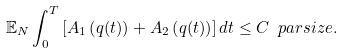<formula> <loc_0><loc_0><loc_500><loc_500>\mathbb { E } _ { N } \int _ { 0 } ^ { T } \left [ A _ { 1 } \left ( q ( t ) \right ) + A _ { 2 } \left ( q ( t ) \right ) \right ] d t \leq C \ p a r s i z e .</formula> 